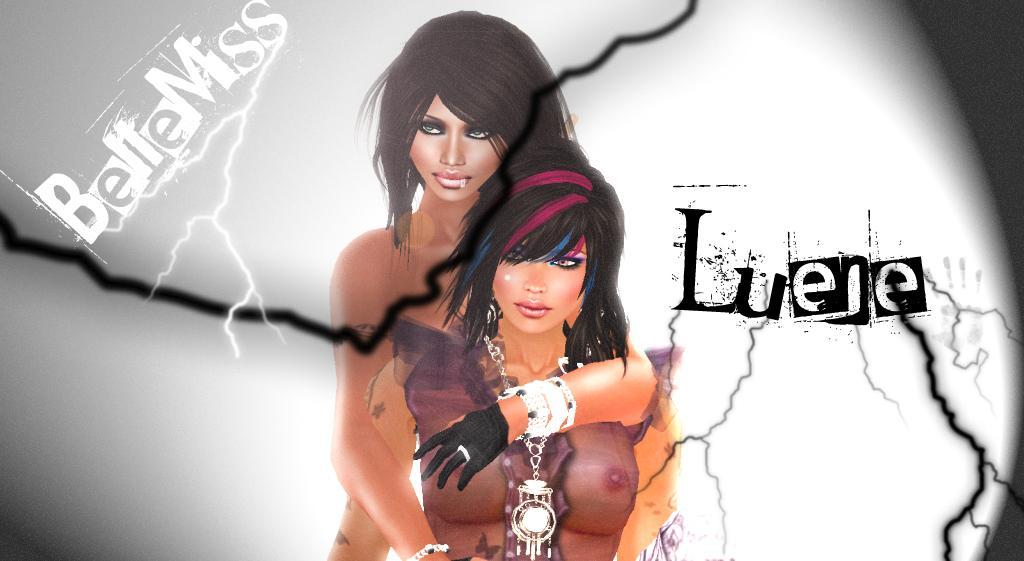How would you summarize this image in a sentence or two? In this picture I can see there is an animated image of two women, there is something written on the image and there is a thunder and there is a white surface in the backdrop. 